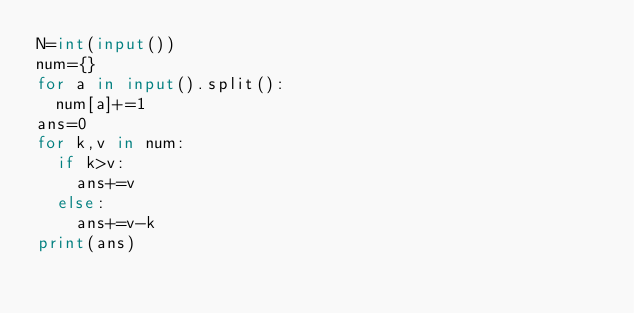Convert code to text. <code><loc_0><loc_0><loc_500><loc_500><_Python_>N=int(input())
num={}
for a in input().split():
  num[a]+=1
ans=0
for k,v in num:
  if k>v:
    ans+=v
  else:
    ans+=v-k
print(ans)</code> 